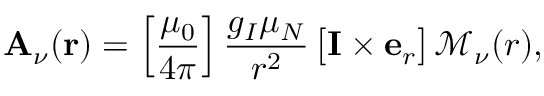Convert formula to latex. <formula><loc_0><loc_0><loc_500><loc_500>A _ { \nu } ( r ) = \left [ { \frac { { \mu _ { 0 } } } { 4 \pi } } \right ] \frac { g _ { I } \mu _ { N } } { r ^ { 2 } } \, \left [ I \times e _ { r } \right ] \, \mathcal { M } _ { \nu } ( r ) ,</formula> 